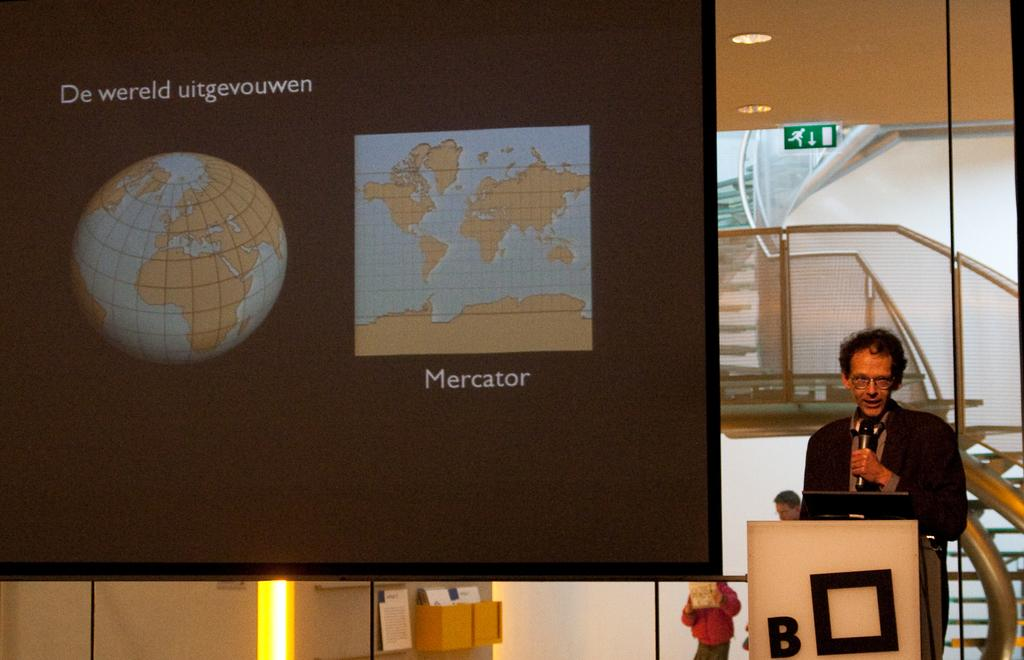What is the main object in the image? There is a screen in the image. What else can be seen in the background? There is a wall in the image. Is there any source of light visible? Yes, there is a light in the image. Are there any people present in the image? Yes, there are people present in the image. Can you describe the person standing in the front? The person in the front is wearing a black color jacket and holding a mic. What type of cart is being used to transport knowledge in the image? There is no cart or knowledge transportation depicted in the image. How many rolls are visible on the person's clothing in the image? The person in the front is wearing a black color jacket, and there are no rolls visible on their clothing. 